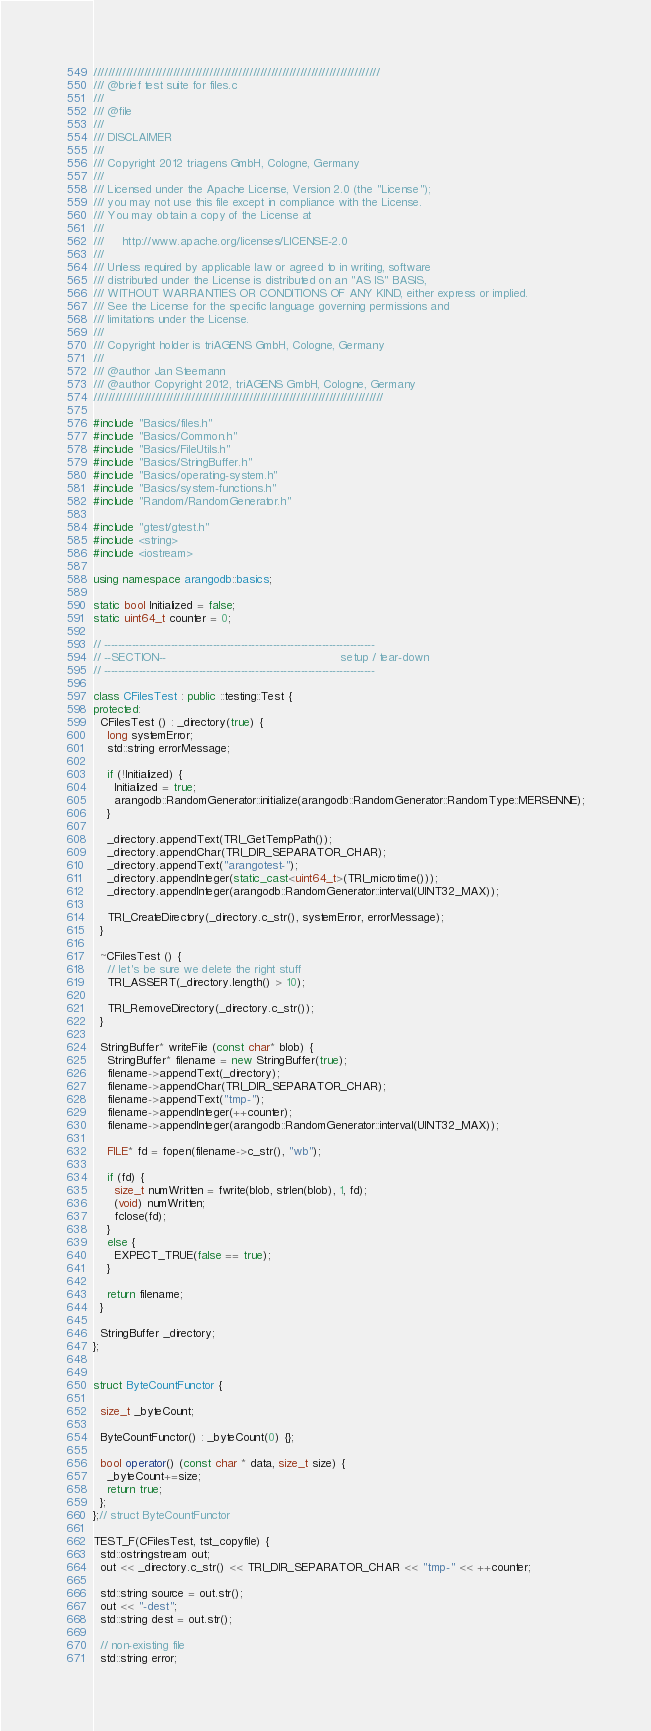Convert code to text. <code><loc_0><loc_0><loc_500><loc_500><_C++_>///////////////////////////////////////////////////////////////////////////////
/// @brief test suite for files.c
///
/// @file
///
/// DISCLAIMER
///
/// Copyright 2012 triagens GmbH, Cologne, Germany
///
/// Licensed under the Apache License, Version 2.0 (the "License");
/// you may not use this file except in compliance with the License.
/// You may obtain a copy of the License at
///
///     http://www.apache.org/licenses/LICENSE-2.0
///
/// Unless required by applicable law or agreed to in writing, software
/// distributed under the License is distributed on an "AS IS" BASIS,
/// WITHOUT WARRANTIES OR CONDITIONS OF ANY KIND, either express or implied.
/// See the License for the specific language governing permissions and
/// limitations under the License.
///
/// Copyright holder is triAGENS GmbH, Cologne, Germany
///
/// @author Jan Steemann
/// @author Copyright 2012, triAGENS GmbH, Cologne, Germany
////////////////////////////////////////////////////////////////////////////////

#include "Basics/files.h"
#include "Basics/Common.h"
#include "Basics/FileUtils.h"
#include "Basics/StringBuffer.h"
#include "Basics/operating-system.h"
#include "Basics/system-functions.h"
#include "Random/RandomGenerator.h"

#include "gtest/gtest.h"
#include <string>
#include <iostream>

using namespace arangodb::basics;

static bool Initialized = false;
static uint64_t counter = 0;

// -----------------------------------------------------------------------------
// --SECTION--                                                 setup / tear-down
// -----------------------------------------------------------------------------

class CFilesTest : public ::testing::Test {
protected:
  CFilesTest () : _directory(true) {
    long systemError;
    std::string errorMessage;

    if (!Initialized) {
      Initialized = true;
      arangodb::RandomGenerator::initialize(arangodb::RandomGenerator::RandomType::MERSENNE);
    }

    _directory.appendText(TRI_GetTempPath());
    _directory.appendChar(TRI_DIR_SEPARATOR_CHAR);
    _directory.appendText("arangotest-");
    _directory.appendInteger(static_cast<uint64_t>(TRI_microtime()));
    _directory.appendInteger(arangodb::RandomGenerator::interval(UINT32_MAX));

    TRI_CreateDirectory(_directory.c_str(), systemError, errorMessage);
  }

  ~CFilesTest () {
    // let's be sure we delete the right stuff
    TRI_ASSERT(_directory.length() > 10);

    TRI_RemoveDirectory(_directory.c_str());
  }

  StringBuffer* writeFile (const char* blob) {
    StringBuffer* filename = new StringBuffer(true);
    filename->appendText(_directory);
    filename->appendChar(TRI_DIR_SEPARATOR_CHAR);
    filename->appendText("tmp-");
    filename->appendInteger(++counter);
    filename->appendInteger(arangodb::RandomGenerator::interval(UINT32_MAX));

    FILE* fd = fopen(filename->c_str(), "wb");

    if (fd) {
      size_t numWritten = fwrite(blob, strlen(blob), 1, fd);
      (void) numWritten;
      fclose(fd);
    }
    else {
      EXPECT_TRUE(false == true);
    }

    return filename;
  }

  StringBuffer _directory;
};


struct ByteCountFunctor {

  size_t _byteCount;

  ByteCountFunctor() : _byteCount(0) {};

  bool operator() (const char * data, size_t size) {
    _byteCount+=size;
    return true;
  };
};// struct ByteCountFunctor

TEST_F(CFilesTest, tst_copyfile) {
  std::ostringstream out;
  out << _directory.c_str() << TRI_DIR_SEPARATOR_CHAR << "tmp-" << ++counter;
  
  std::string source = out.str();
  out << "-dest";
  std::string dest = out.str();

  // non-existing file
  std::string error;</code> 